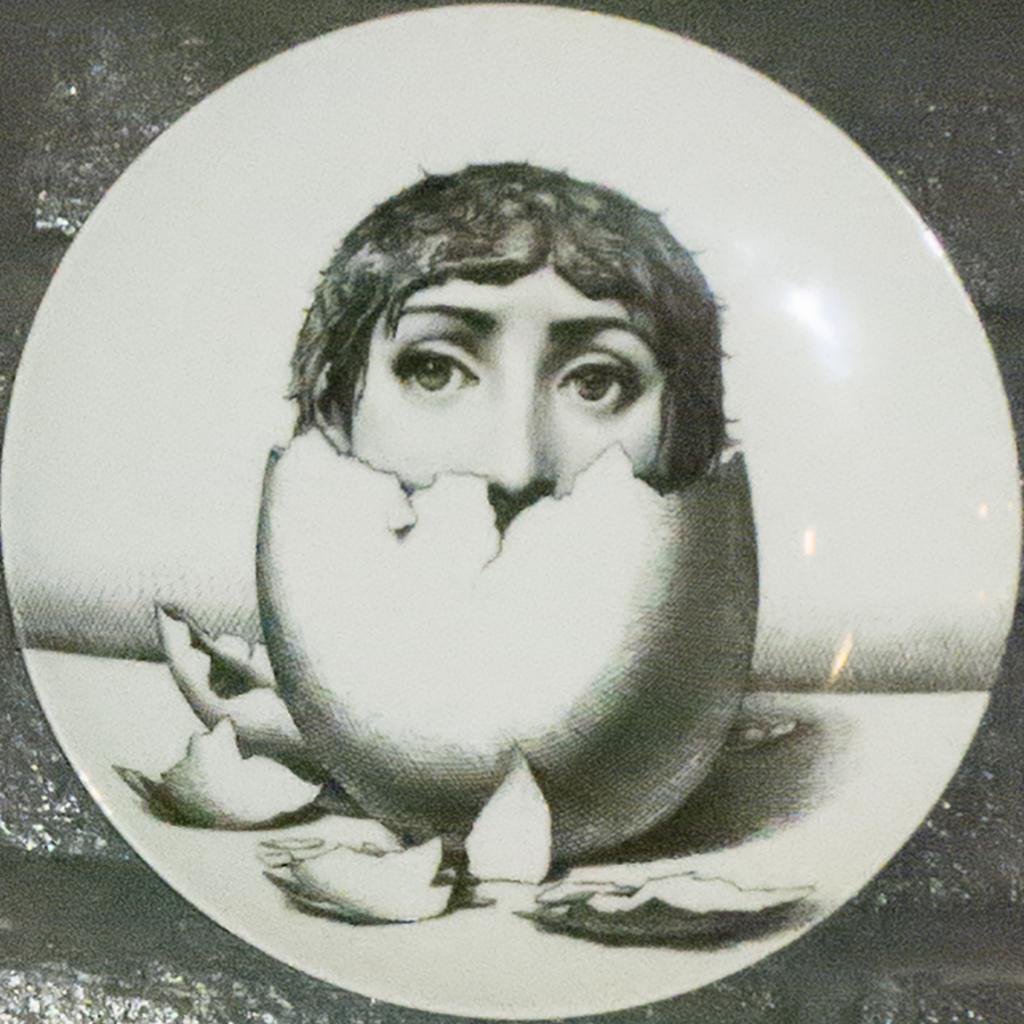In one or two sentences, can you explain what this image depicts? In this picture there is a plate which is kept on the table. In the center of the plate I can see the design of a person's face on the eggshells. 